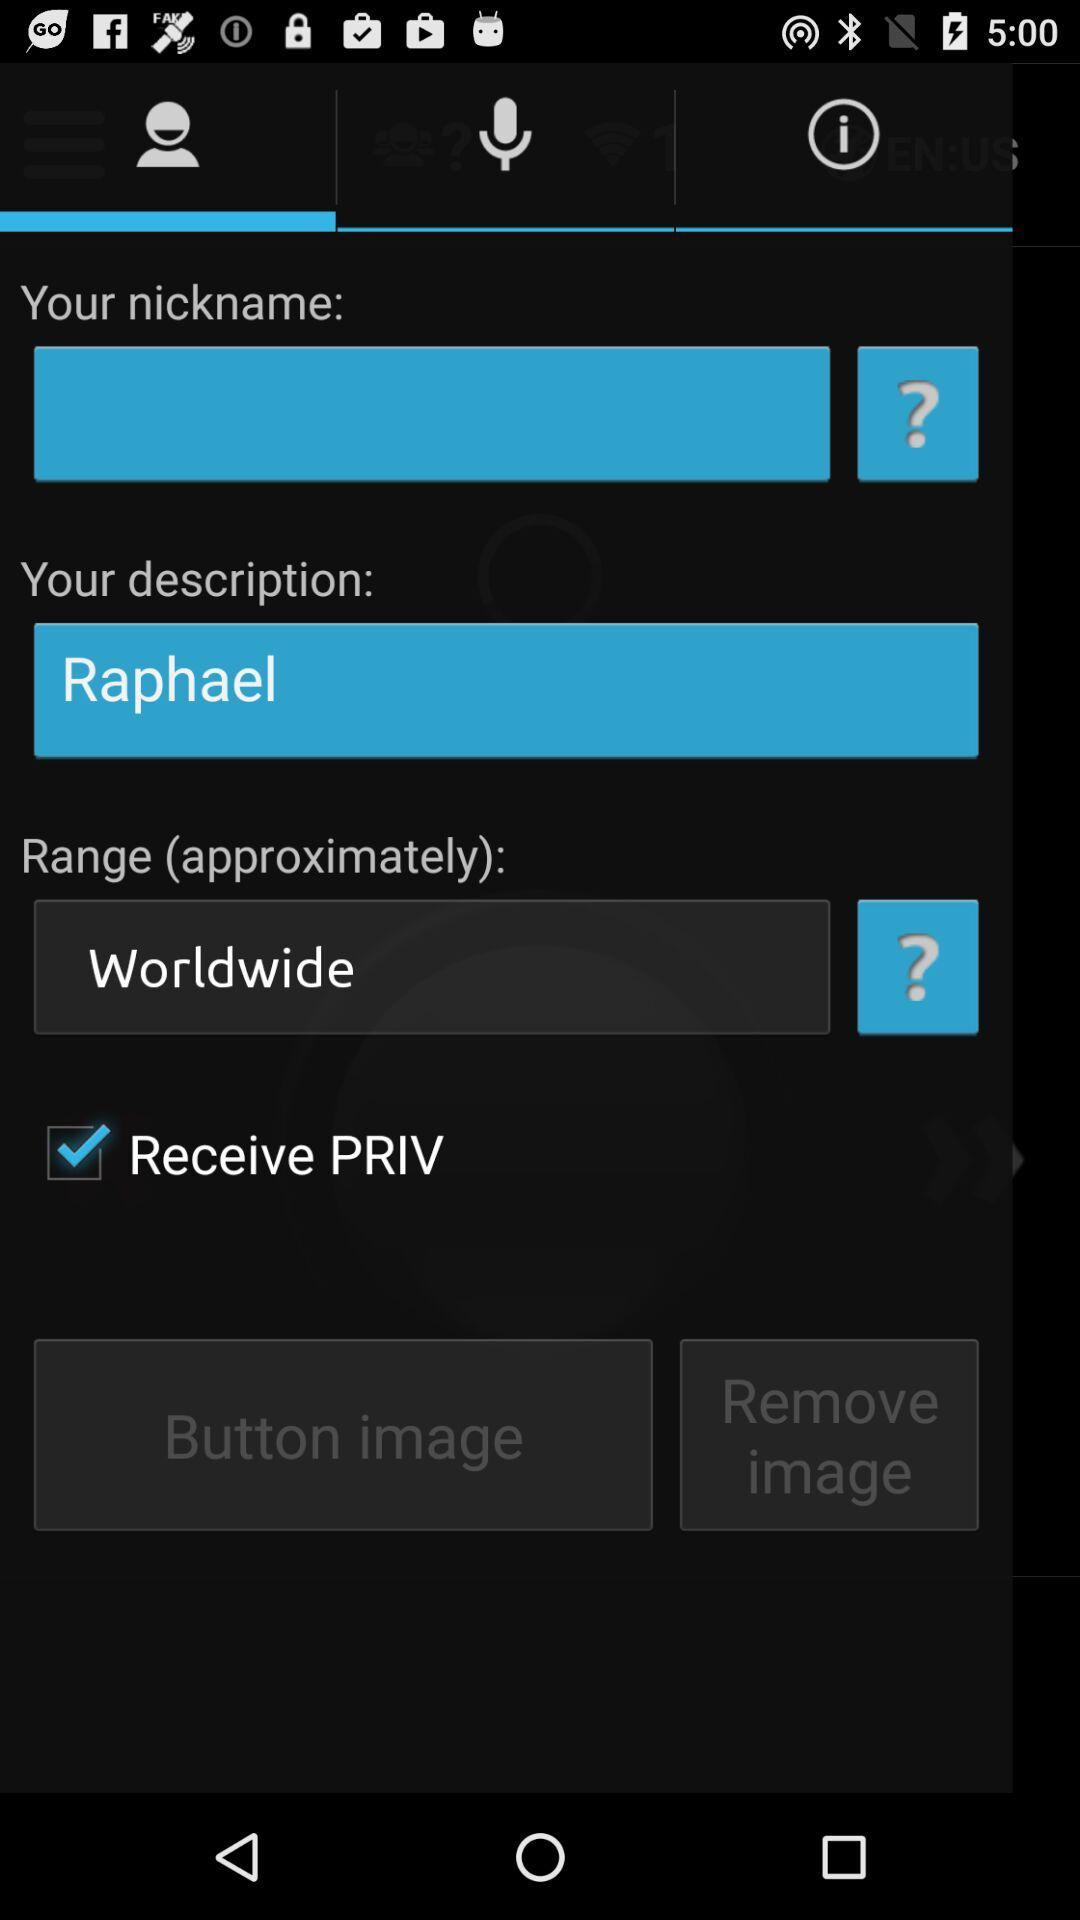How many text inputs are in the screen?
Answer the question using a single word or phrase. 3 